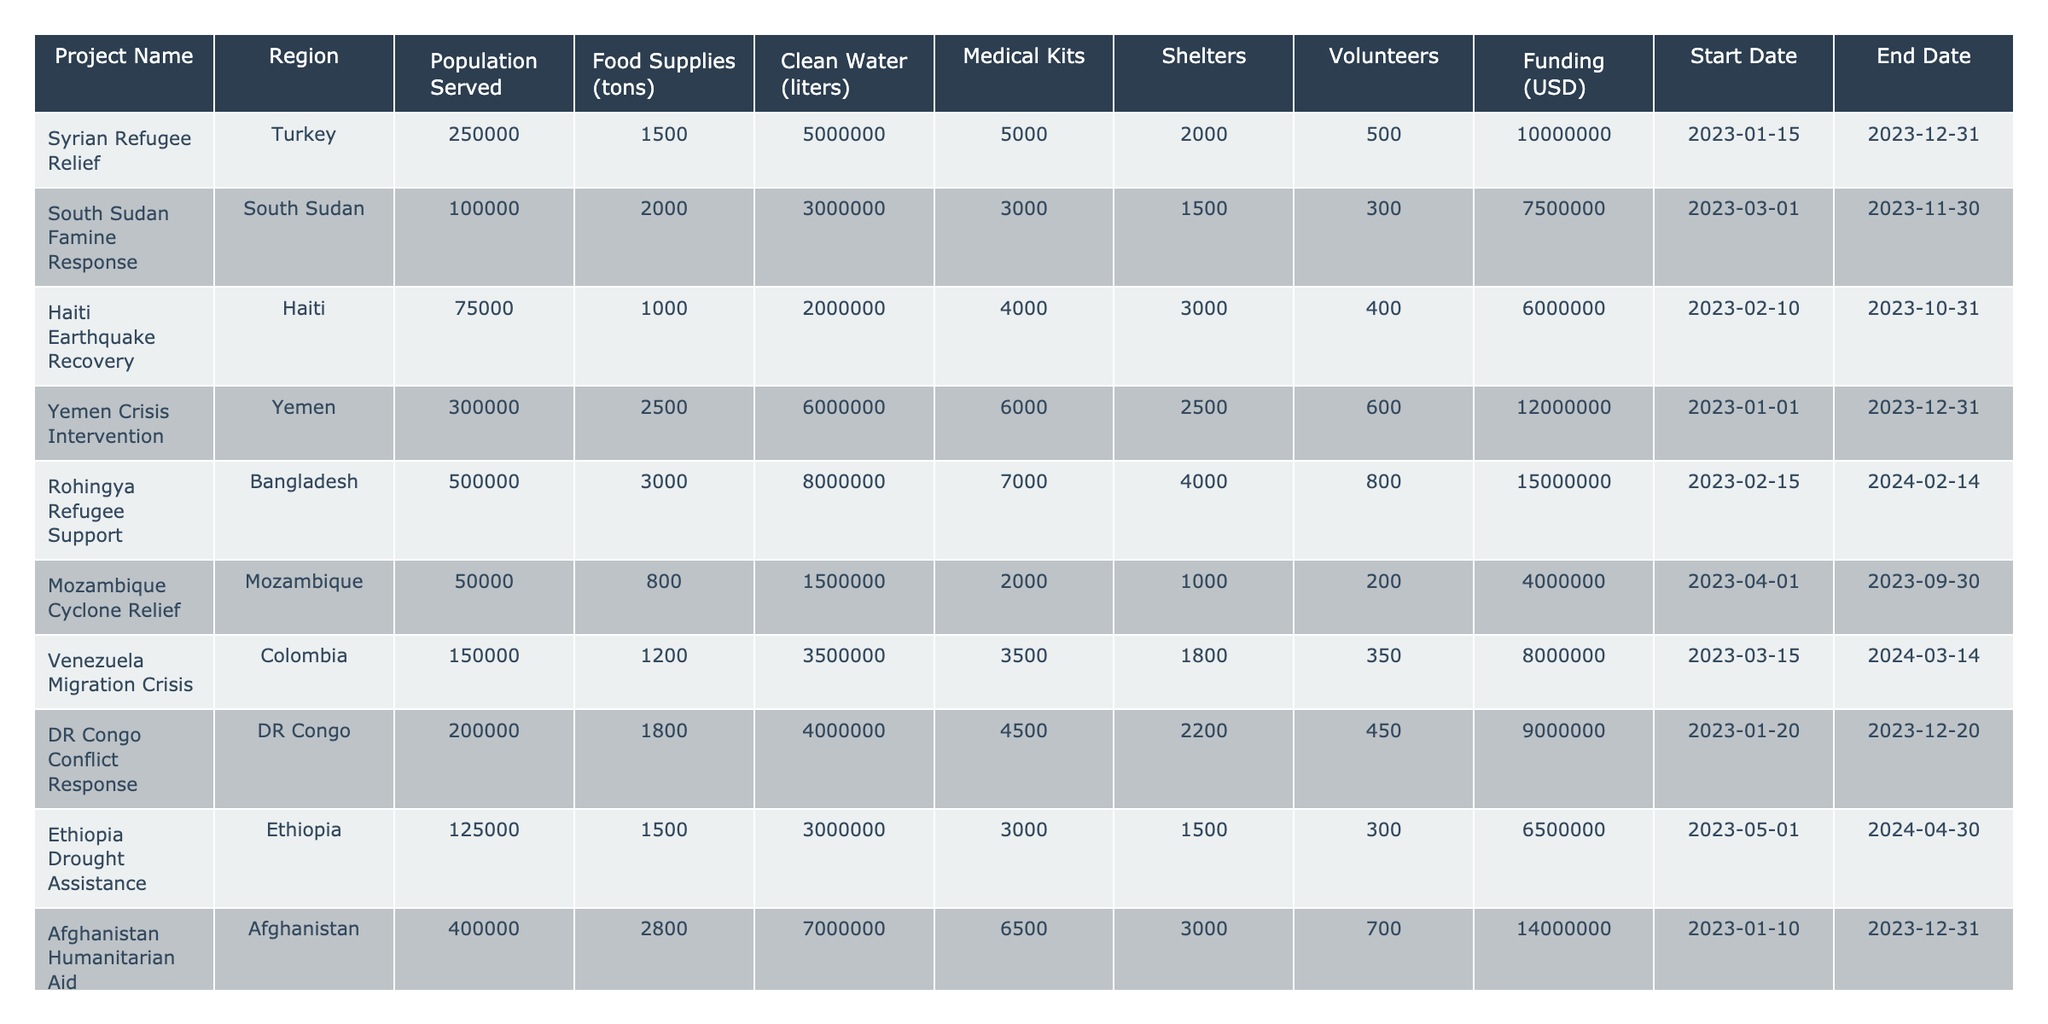What is the total population served by all the projects listed in the table? The populations served by each project are: 250000, 100000, 75000, 300000, 500000, 50000, 150000, 200000, 125000, and 400000. Adding them (250000 + 100000 + 75000 + 300000 + 500000 + 50000 + 150000 + 200000 + 125000 + 400000 = 1950000) gives a total population served of 1,950,000.
Answer: 1950000 Which project has the highest funding allocated? The funding for each project is: 10000000, 7500000, 6000000, 12000000, 15000000, 4000000, 8000000, 9000000, 6500000, and 14000000. The highest funding allocation is 15000000 for the Rohingya Refugee Support project.
Answer: 15000000 Is the total food supply for the South Sudan Famine Response greater than that of the Mozambique Cyclone Relief project? The food supply for South Sudan is 2000 tons, and for Mozambique, it is 800 tons. Since 2000 is greater than 800, South Sudan's food supply is indeed greater.
Answer: Yes What is the average amount of clean water provided across all projects? The total clean water provided is 5000000 + 3000000 + 2000000 + 6000000 + 8000000 + 1500000 + 3500000 + 4000000 + 3000000 + 7000000 = 33500000 liters. There are 10 projects, so the average is 33500000 / 10 = 3350000 liters.
Answer: 3350000 Which project has the fewest medical kits distributed? The number of medical kits for each project is: 5000, 3000, 4000, 6000, 7000, 2000, 3500, 4500, 3000, and 6500. The fewest medical kits are 2000 for the Mozambique Cyclone Relief project.
Answer: Mozambique Cyclone Relief How many more shelters are provided in the Yemen Crisis Intervention compared to the Haiti Earthquake Recovery? Yemen has 6000 shelters and Haiti has 4000. The difference is 6000 - 4000 = 2000 shelters, meaning Yemen provides 2000 more.
Answer: 2000 Which region has the second lowest population served? The populations served are: Turkey (250000), South Sudan (100000), Haiti (75000), Yemen (300000), Bangladesh (500000), Mozambique (50000), Colombia (150000), DR Congo (200000), Ethiopia (125000), and Afghanistan (400000). The second lowest is 100000 in South Sudan.
Answer: South Sudan If we sum the funding of all projects, how much funding has been allocated in total? The total funding is computed as: 10000000 + 7500000 + 6000000 + 12000000 + 15000000 + 4000000 + 8000000 + 9000000 + 6500000 + 14000000 = 85000000 USD.
Answer: 85000000 How does the total amount of food supplied to the Rohingya Refugee Support project compare to the total supplied to the Haiti Earthquake Recovery project? The food supplies are 3000 tons for Rohingya and 1000 tons for Haiti. Since 3000 is greater than 1000, Rohingya has more food.
Answer: Rohingya has more food What is the ratio of volunteers to shelters in the Afghanistan Humanitarian Aid project? In Afghanistan, there are 3000 volunteers and 6500 shelters. The ratio is 3000:6500, which simplifies to 3:6.5 or 6:13 when reduced.
Answer: 6:13 